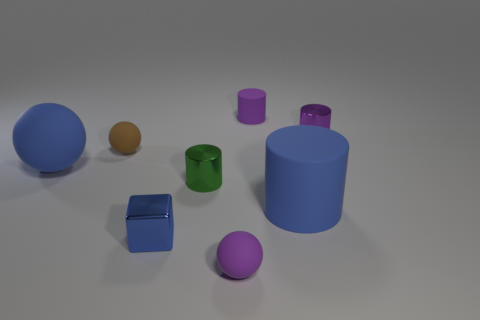Subtract all red cylinders. Subtract all purple balls. How many cylinders are left? 4 Add 1 small gray rubber things. How many objects exist? 9 Subtract all spheres. How many objects are left? 5 Subtract all balls. Subtract all big brown rubber objects. How many objects are left? 5 Add 1 large matte cylinders. How many large matte cylinders are left? 2 Add 4 yellow metallic cubes. How many yellow metallic cubes exist? 4 Subtract 0 gray spheres. How many objects are left? 8 